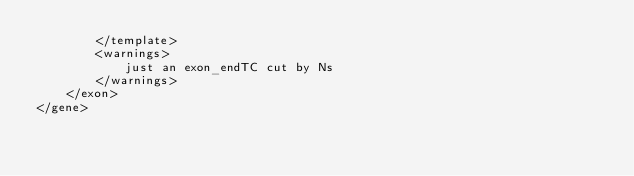Convert code to text. <code><loc_0><loc_0><loc_500><loc_500><_XML_>		</template>
		<warnings>
			just an exon_endTC cut by Ns
		</warnings>
	</exon>
</gene>
</code> 